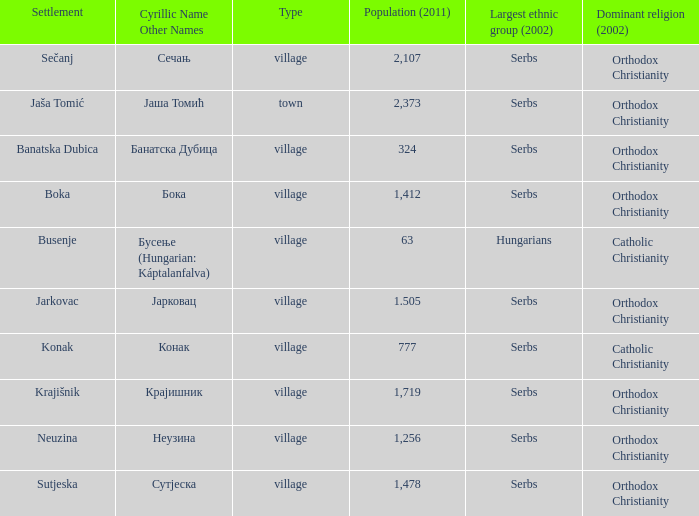In which town can a population of 777 be found? Конак. 